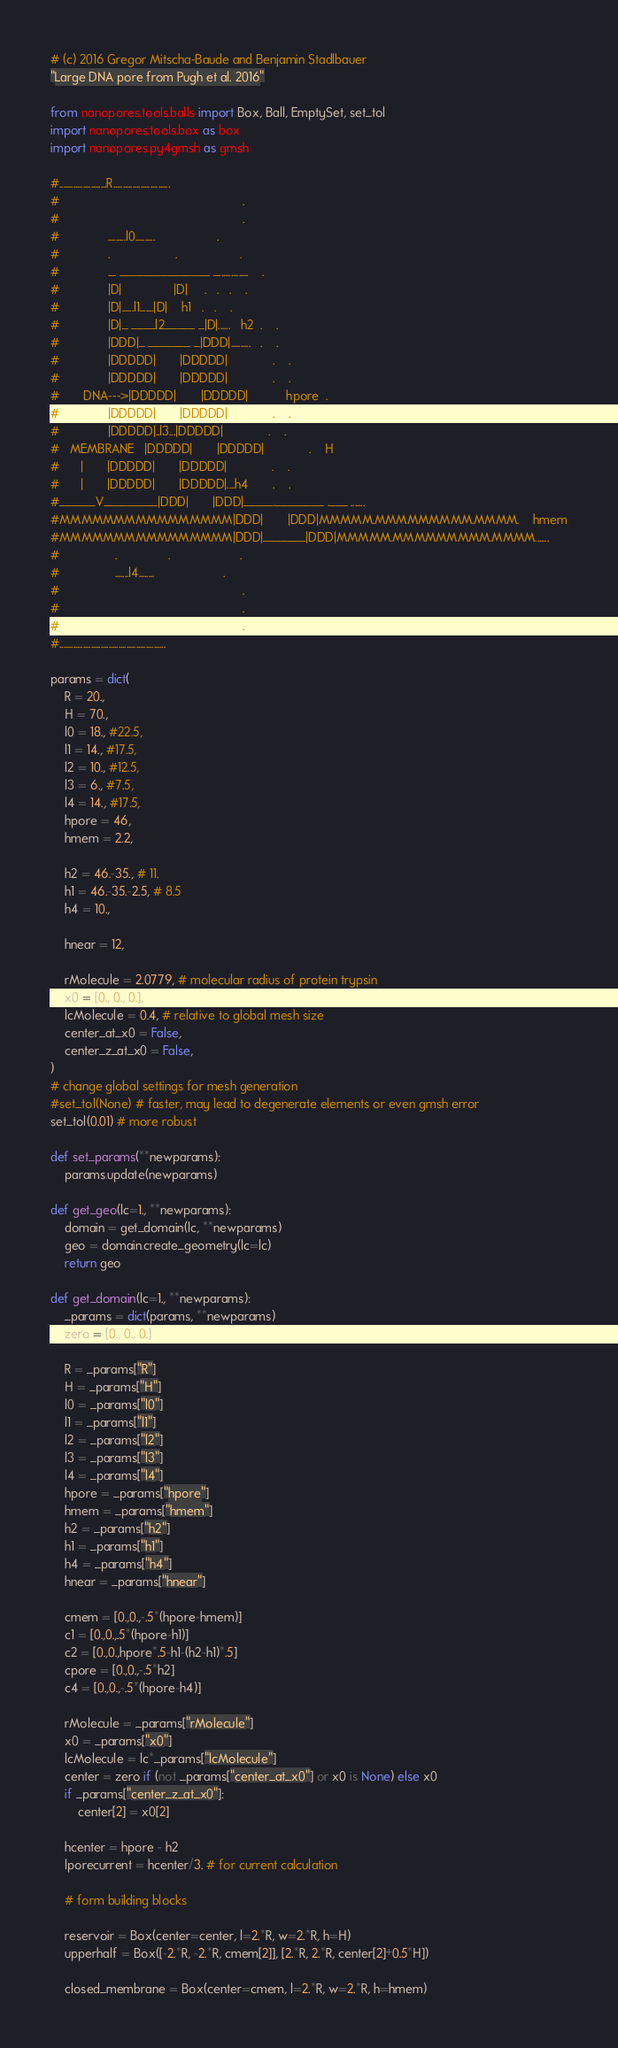Convert code to text. <code><loc_0><loc_0><loc_500><loc_500><_Python_># (c) 2016 Gregor Mitscha-Baude and Benjamin Stadlbauer
"Large DNA pore from Pugh et al. 2016"

from nanopores.tools.balls import Box, Ball, EmptySet, set_tol
import nanopores.tools.box as box
import nanopores.py4gmsh as gmsh

#........................R.............................
#                                                     .
#                                                     .
#              .........l0..........                  .
#              .                   .                  .
#              ._ _______________ _...............    .
#              |D|               |D|     .   .   .    .
#              |D|......l1.......|D|    h1   .   .    .
#              |D|_ ____l2_____ _|D|......   h2  .    .
#              |DDD|_ _______ _|DDD|..........   .    .
#              |DDDDD|       |DDDDD|             .    .
#              |DDDDD|       |DDDDD|             .    .
#       DNA--->|DDDDD|       |DDDDD|           hpore  .
#              |DDDDD|       |DDDDD|             .    .
#              |DDDDD|..l3...|DDDDD|             .    .
#   MEMBRANE   |DDDDD|       |DDDDD|             .    H
#      |       |DDDDD|       |DDDDD|             .    .
#      |       |DDDDD|       |DDDDD|....h4       .    .
#______V_________|DDD|       |DDD|_____.________ .___ .......
#MMMMMMMMMMMMMMMM|DDD|       |DDD|MMMMM.MMMMMMMMM.MMMM.    hmem
#MMMMMMMMMMMMMMMM|DDD|_______|DDD|MMMMM.MMMMMMMMM.MMMM.......
#                .               .                    .
#                .......l4........                    .
#                                                     .
#                                                     .
#                                                     .
#......................................................

params = dict(
    R = 20.,
    H = 70.,
    l0 = 18., #22.5,
    l1 = 14., #17.5,
    l2 = 10., #12.5,
    l3 = 6., #7.5,
    l4 = 14., #17.5,
    hpore = 46,
    hmem = 2.2,

    h2 = 46.-35., # 11.
    h1 = 46.-35.-2.5, # 8.5
    h4 = 10.,

    hnear = 12,

    rMolecule = 2.0779, # molecular radius of protein trypsin
    x0 = [0., 0., 0.],
    lcMolecule = 0.4, # relative to global mesh size
    center_at_x0 = False,
    center_z_at_x0 = False,
)
# change global settings for mesh generation
#set_tol(None) # faster, may lead to degenerate elements or even gmsh error
set_tol(0.01) # more robust

def set_params(**newparams):
    params.update(newparams)

def get_geo(lc=1., **newparams):
    domain = get_domain(lc, **newparams)
    geo = domain.create_geometry(lc=lc)
    return geo

def get_domain(lc=1., **newparams):
    _params = dict(params, **newparams)
    zero = [0., 0., 0.]

    R = _params["R"]
    H = _params["H"]
    l0 = _params["l0"]
    l1 = _params["l1"]
    l2 = _params["l2"]
    l3 = _params["l3"]
    l4 = _params["l4"]
    hpore = _params["hpore"]
    hmem = _params["hmem"]
    h2 = _params["h2"]
    h1 = _params["h1"]
    h4 = _params["h4"]
    hnear = _params["hnear"]

    cmem = [0.,0.,-.5*(hpore-hmem)]
    c1 = [0.,0.,.5*(hpore-h1)]
    c2 = [0.,0.,hpore*.5-h1-(h2-h1)*.5]
    cpore = [0.,0.,-.5*h2]
    c4 = [0.,0.,-.5*(hpore-h4)]

    rMolecule = _params["rMolecule"]
    x0 = _params["x0"]
    lcMolecule = lc*_params["lcMolecule"]
    center = zero if (not _params["center_at_x0"] or x0 is None) else x0
    if _params["center_z_at_x0"]:
        center[2] = x0[2]

    hcenter = hpore - h2
    lporecurrent = hcenter/3. # for current calculation

    # form building blocks

    reservoir = Box(center=center, l=2.*R, w=2.*R, h=H)
    upperhalf = Box([-2.*R, -2.*R, cmem[2]], [2.*R, 2.*R, center[2]+0.5*H])

    closed_membrane = Box(center=cmem, l=2.*R, w=2.*R, h=hmem)</code> 